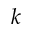Convert formula to latex. <formula><loc_0><loc_0><loc_500><loc_500>k</formula> 